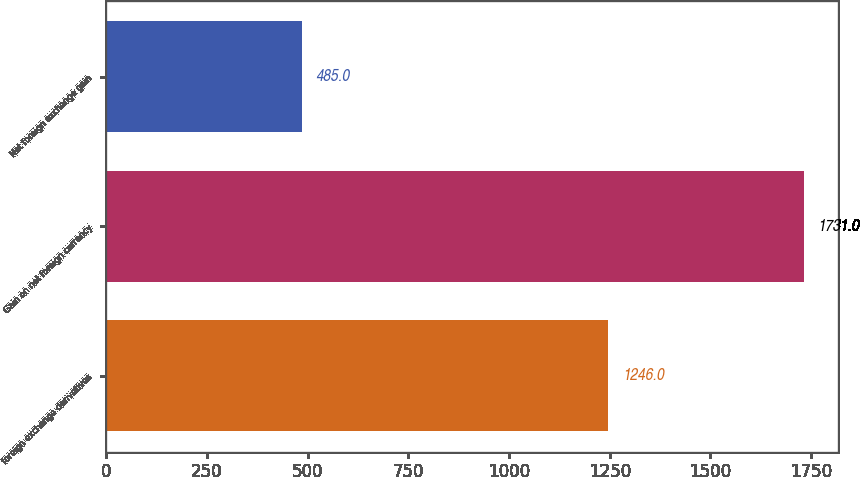Convert chart. <chart><loc_0><loc_0><loc_500><loc_500><bar_chart><fcel>foreign exchange derivatives<fcel>Gain on net foreign currency<fcel>Net foreign exchange gain<nl><fcel>1246<fcel>1731<fcel>485<nl></chart> 